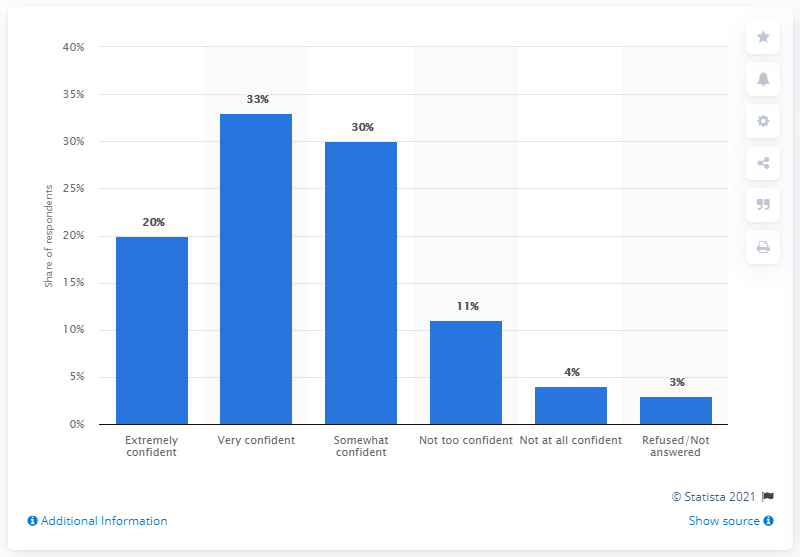Give some essential details in this illustration. Out of the people surveyed, 33% responded with 'Very confident.' Out of the options available, only three have a percentage below 15%. 